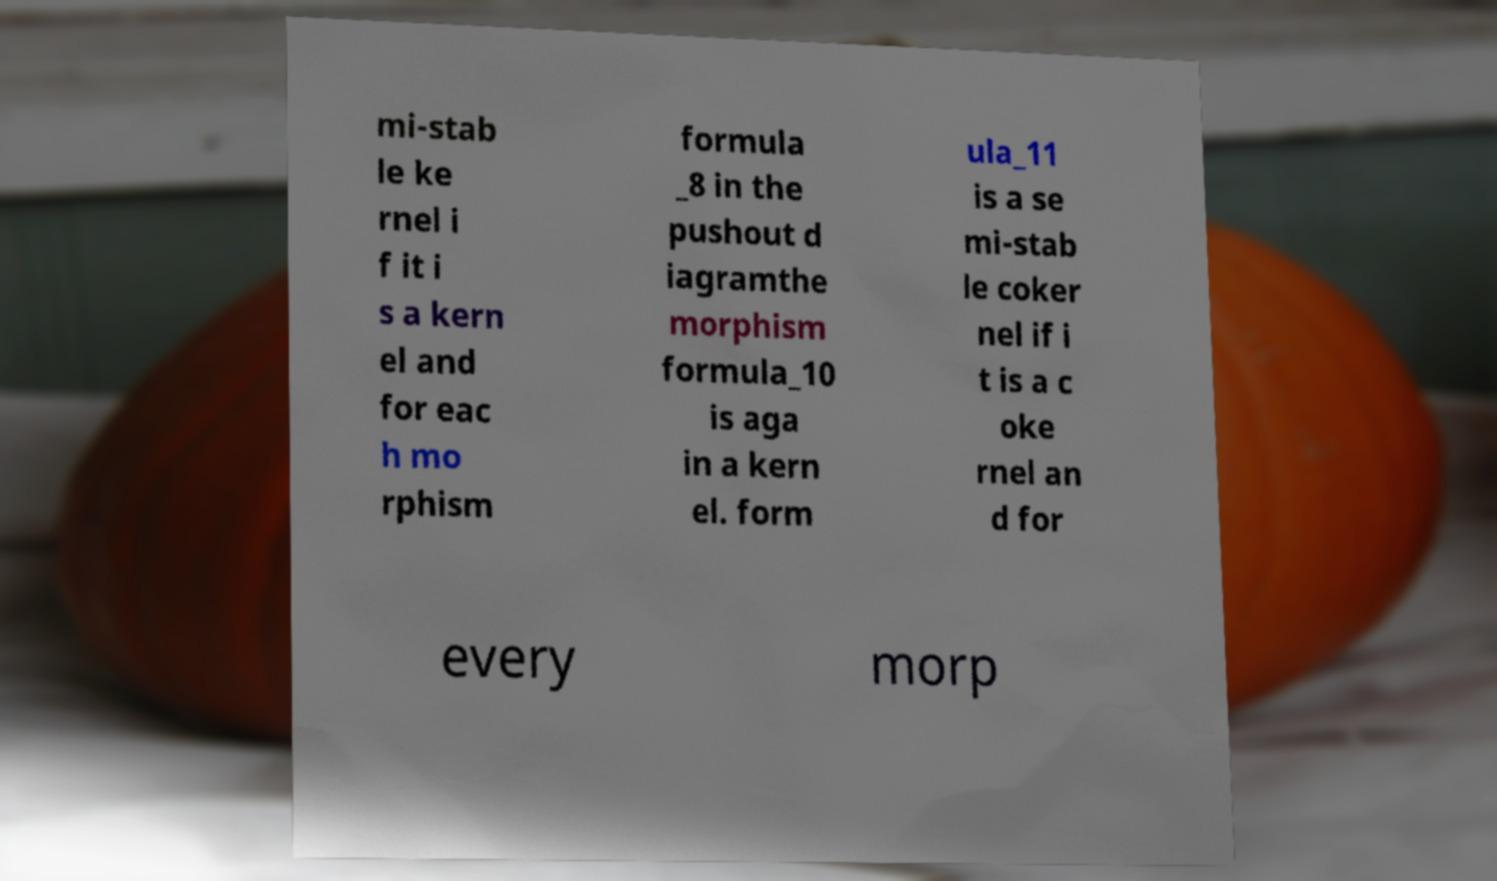I need the written content from this picture converted into text. Can you do that? mi-stab le ke rnel i f it i s a kern el and for eac h mo rphism formula _8 in the pushout d iagramthe morphism formula_10 is aga in a kern el. form ula_11 is a se mi-stab le coker nel if i t is a c oke rnel an d for every morp 